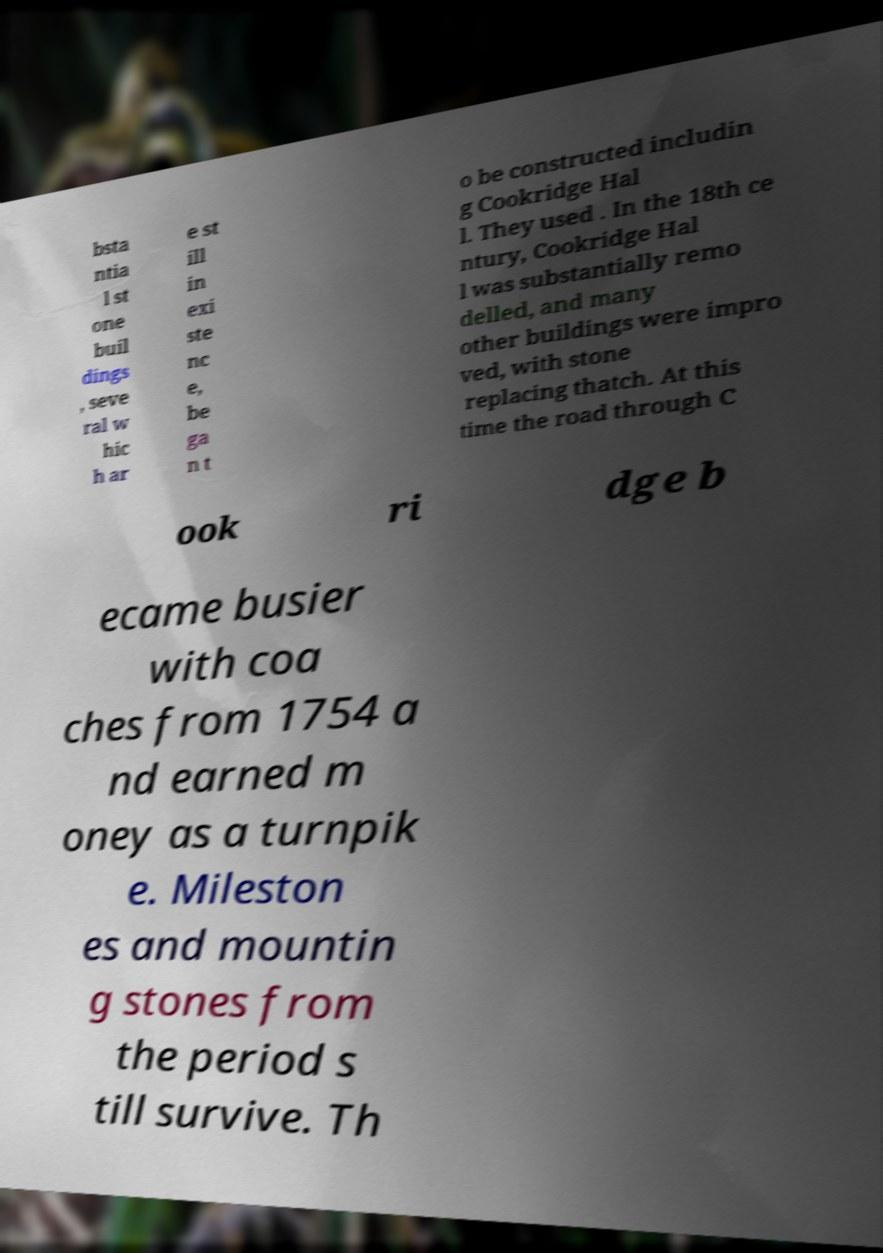Could you assist in decoding the text presented in this image and type it out clearly? bsta ntia l st one buil dings , seve ral w hic h ar e st ill in exi ste nc e, be ga n t o be constructed includin g Cookridge Hal l. They used . In the 18th ce ntury, Cookridge Hal l was substantially remo delled, and many other buildings were impro ved, with stone replacing thatch. At this time the road through C ook ri dge b ecame busier with coa ches from 1754 a nd earned m oney as a turnpik e. Mileston es and mountin g stones from the period s till survive. Th 